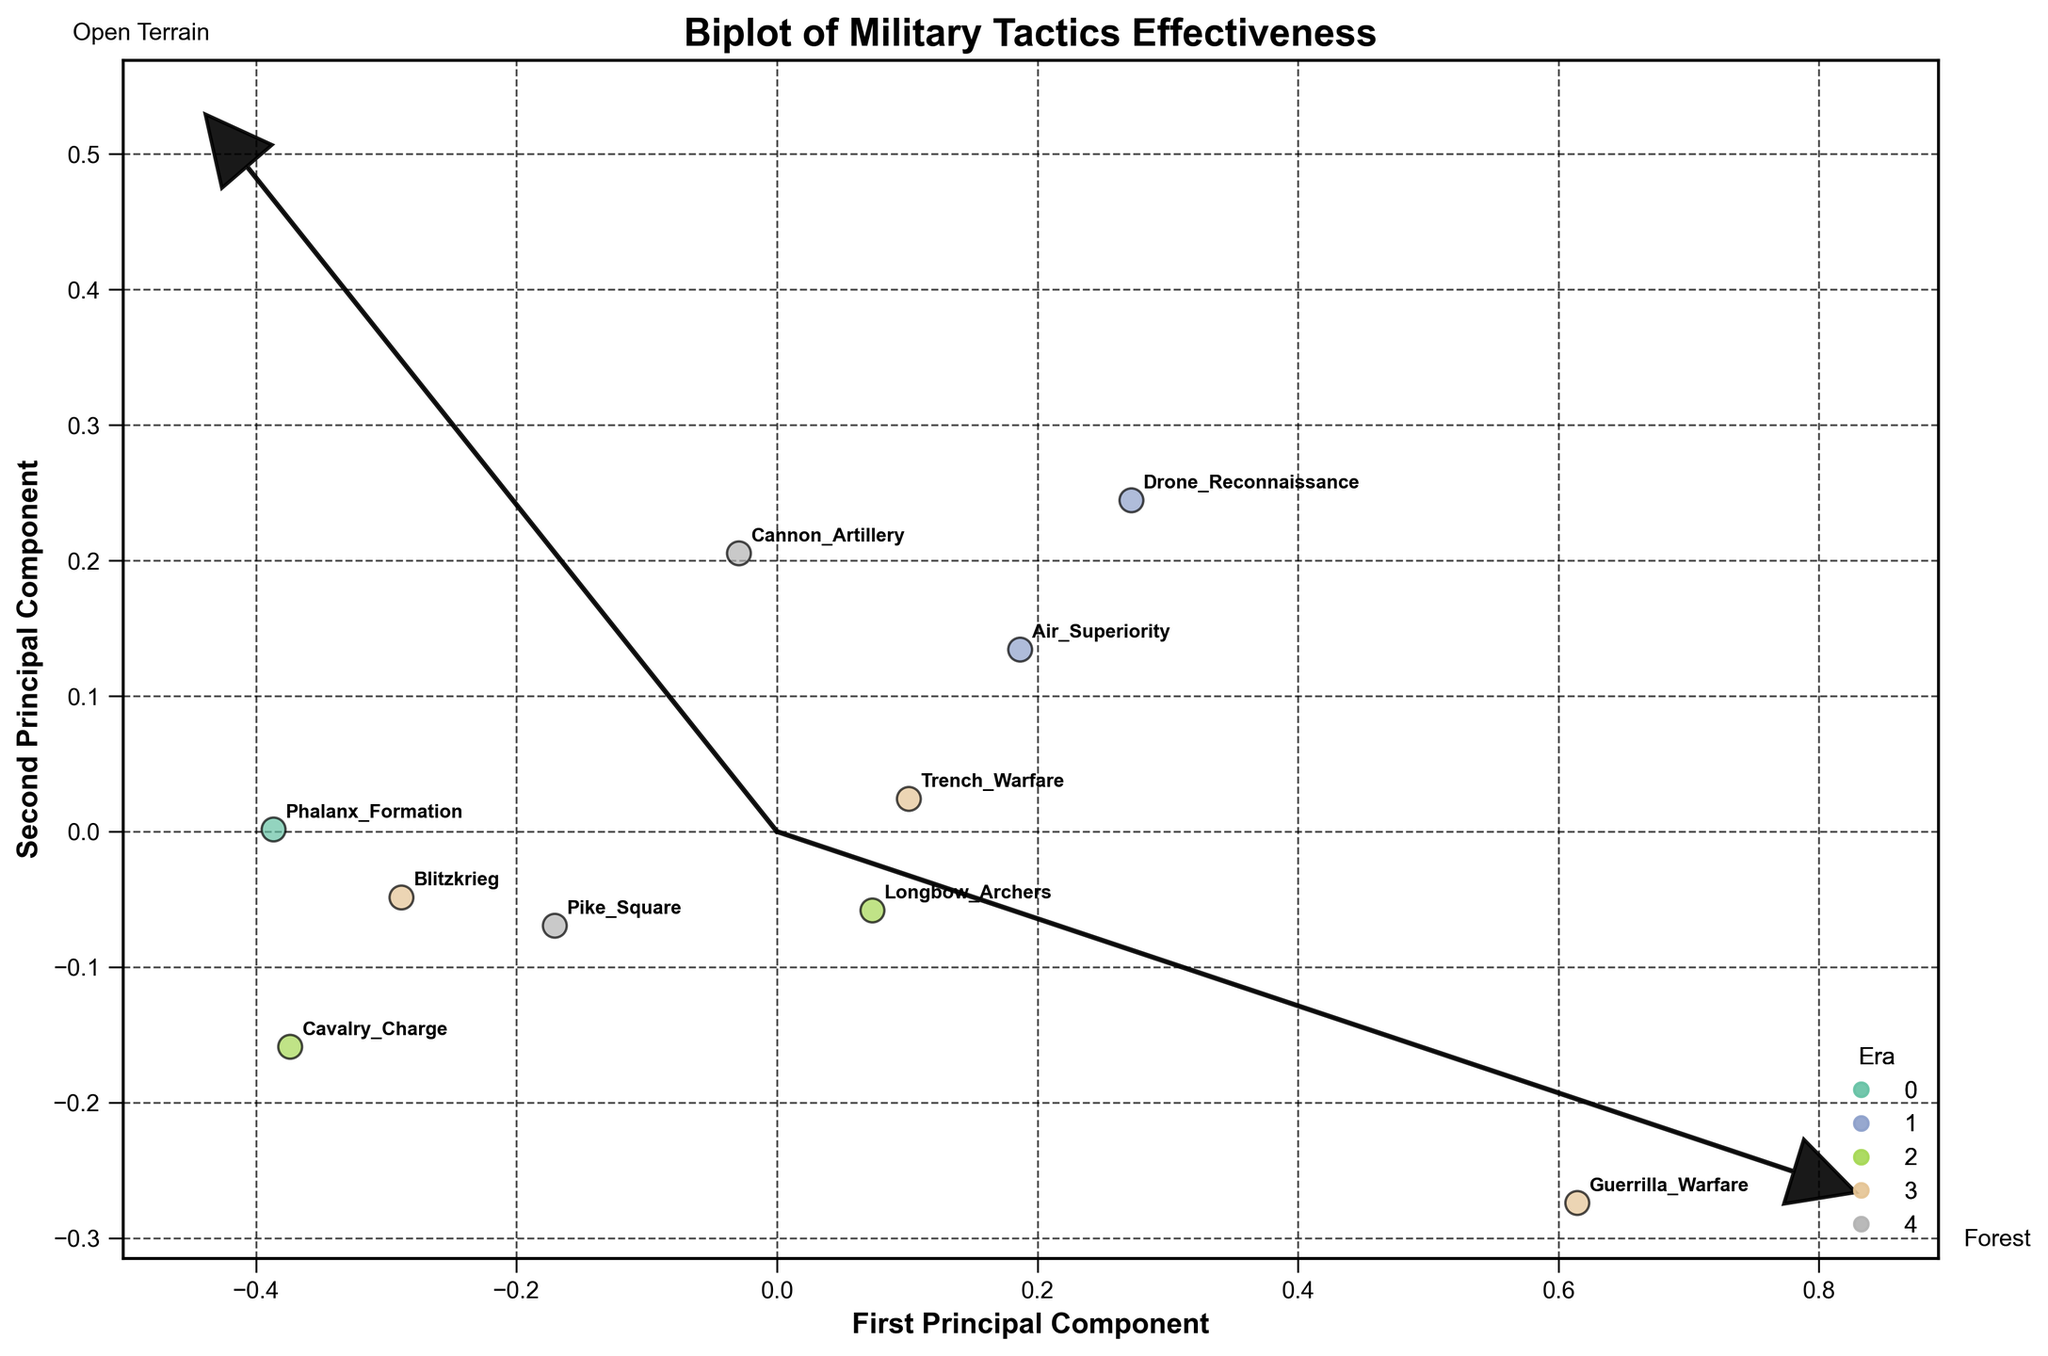What's the title of the biplot? The title is usually found at the top of a plot. Here it reads "Biplot of Military Tactics Effectiveness" as mentioned in the code provided.
Answer: Biplot of Military Tactics Effectiveness How many tactics are represented in the plot? Each tactic is represented by a point on the plot. By counting the unique points, we determine there are 10 tactics listed in the dataset.
Answer: 10 Which era has the most data points in the plot? Observing the different color-coded points and the legend, the Modern era has three data points (Guerrilla Warfare, Blitzkrieg, Trench Warfare), which is the highest among all eras.
Answer: Modern Which tactics have the highest effectiveness in open terrain according to the biplot? By referring to the arrows and the data points alignment along the 'Open Terrain' vector, we can see that Phalanx Formation, Cannon Artillery, and Drone Reconnaissance are close to the arrow indicating high effectiveness.
Answer: Phalanx Formation, Cannon Artillery, Drone Reconnaissance Which tactic appears closest to the 'Forest' vector and what era does it belong to? By examining where the 'Forest' vector points and locating the nearest data point to it, Guerrilla Warfare is the closest. Guerrilla Warfare belongs to the Modern era.
Answer: Guerrilla Warfare, Modern Which military tactic is most balanced in terms of effectiveness across different terrains? Looking at the PCA plot, a balanced military tactic would be closer to the origin and equidistant from all feature vectors. Longbow Archers is most balanced because it doesn't show extreme values in any particular direction.
Answer: Longbow Archers Compare the 'Cavalry Charge' and 'Blitzkrieg' in terms of effectiveness across terrain types. Both tactics are plotted on the biplot. By checking the positions and their relation to the feature vectors, Cavalry Charge is more effective in Open Terrain but less in Forest and Mountains compared to Blitzkrieg.
Answer: Cavalry Charge is more effective in Open Terrain; Blitzkrieg is more effective in Forest and Mountains Based on the biplot, which era has tactics that show high effectiveness in Mountain terrains? Checking the feature vector for Mountain terrains and the proximity of data points, Modern tactics (Guerrilla Warfare, Trench Warfare) and Contemporary tactics (Drone Reconnaissance) have high effectiveness.
Answer: Modern, Contemporary Which feature vector points closest to Air Superiority? By locating the position of Air Superiority and checking its nearest feature vector arrow, it is closest to the Mountains vector.
Answer: Mountains What can be inferred about the evolution of military tactics from Ancient to Contemporary eras? Observing the spread of data points from different eras and their positioning, earlier eras (Ancient, Medieval) are more concentrated around Open Terrain, while Contemporary tactics show better balance and effectiveness across diverse terrains.
Answer: Tactics evolved to be more balanced across different terrains 